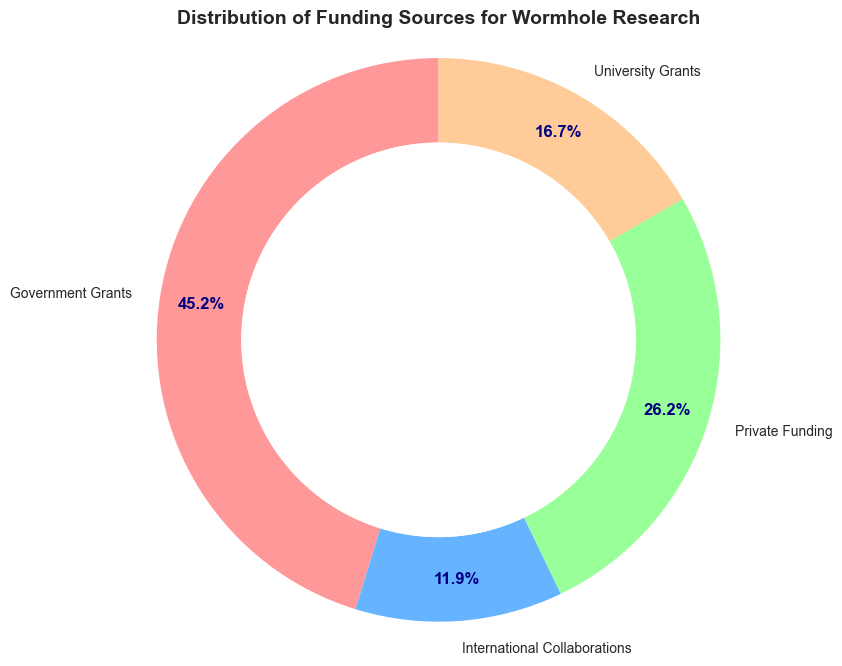What's the total amount of funding from all sources combined? To find the total amount, sum up all individual funding amounts: Government Grants (95 million) + Private Funding (55 million) + University Grants (35 million) + International Collaborations (25 million). This gives 95 + 55 + 35 + 25 = 210 million USD.
Answer: 210 million USD Which funding source provides the highest percentage of the total funding? To determine the highest percentage, look for the largest wedge in the ring chart. The largest wedge is for Government Grants. Government Grants provide 95 million out of 210 million, so the percentage is (95/210) * 100 ≈ 45.2%.
Answer: Government Grants What is the percentage difference between Government Grants and Private Funding? First, find the individual percentages: Government Grants are (95/210) * 100 ≈ 45.2%, and Private Funding is (55/210) * 100 ≈ 26.2%. The difference is 45.2% - 26.2% ≈ 19%.
Answer: 19% How much more funding does Government Grants provide compared to University Grants? Government Grants provide 95 million USD, and University Grants provide 35 million USD. The difference is 95 - 35 = 60 million USD.
Answer: 60 million USD What is the average amount of funding per source? The total funding is 210 million USD, and there are 4 funding sources. The average amount is 210/4 = 52.5 million USD.
Answer: 52.5 million USD Are International Collaborations funding greater than University Grants? International Collaborations funding is 25 million USD, while University Grants funding is 35 million USD. 25 million is less than 35 million.
Answer: No How much funding is obtained through Private Funding and International Collaborations combined? Private Funding is 55 million USD, and International Collaborations are 25 million USD. The combined amount is 55 + 25 = 80 million USD.
Answer: 80 million USD Which two funding sources together provide more than half of the total funding? We need to find combinations that exceed half of the total (210/2 = 105 million USD). Government Grants (95) + Private Funding (55) = 150 million USD, which is more than 105 million. Other combinations do not exceed 105 million.
Answer: Government Grants and Private Funding 